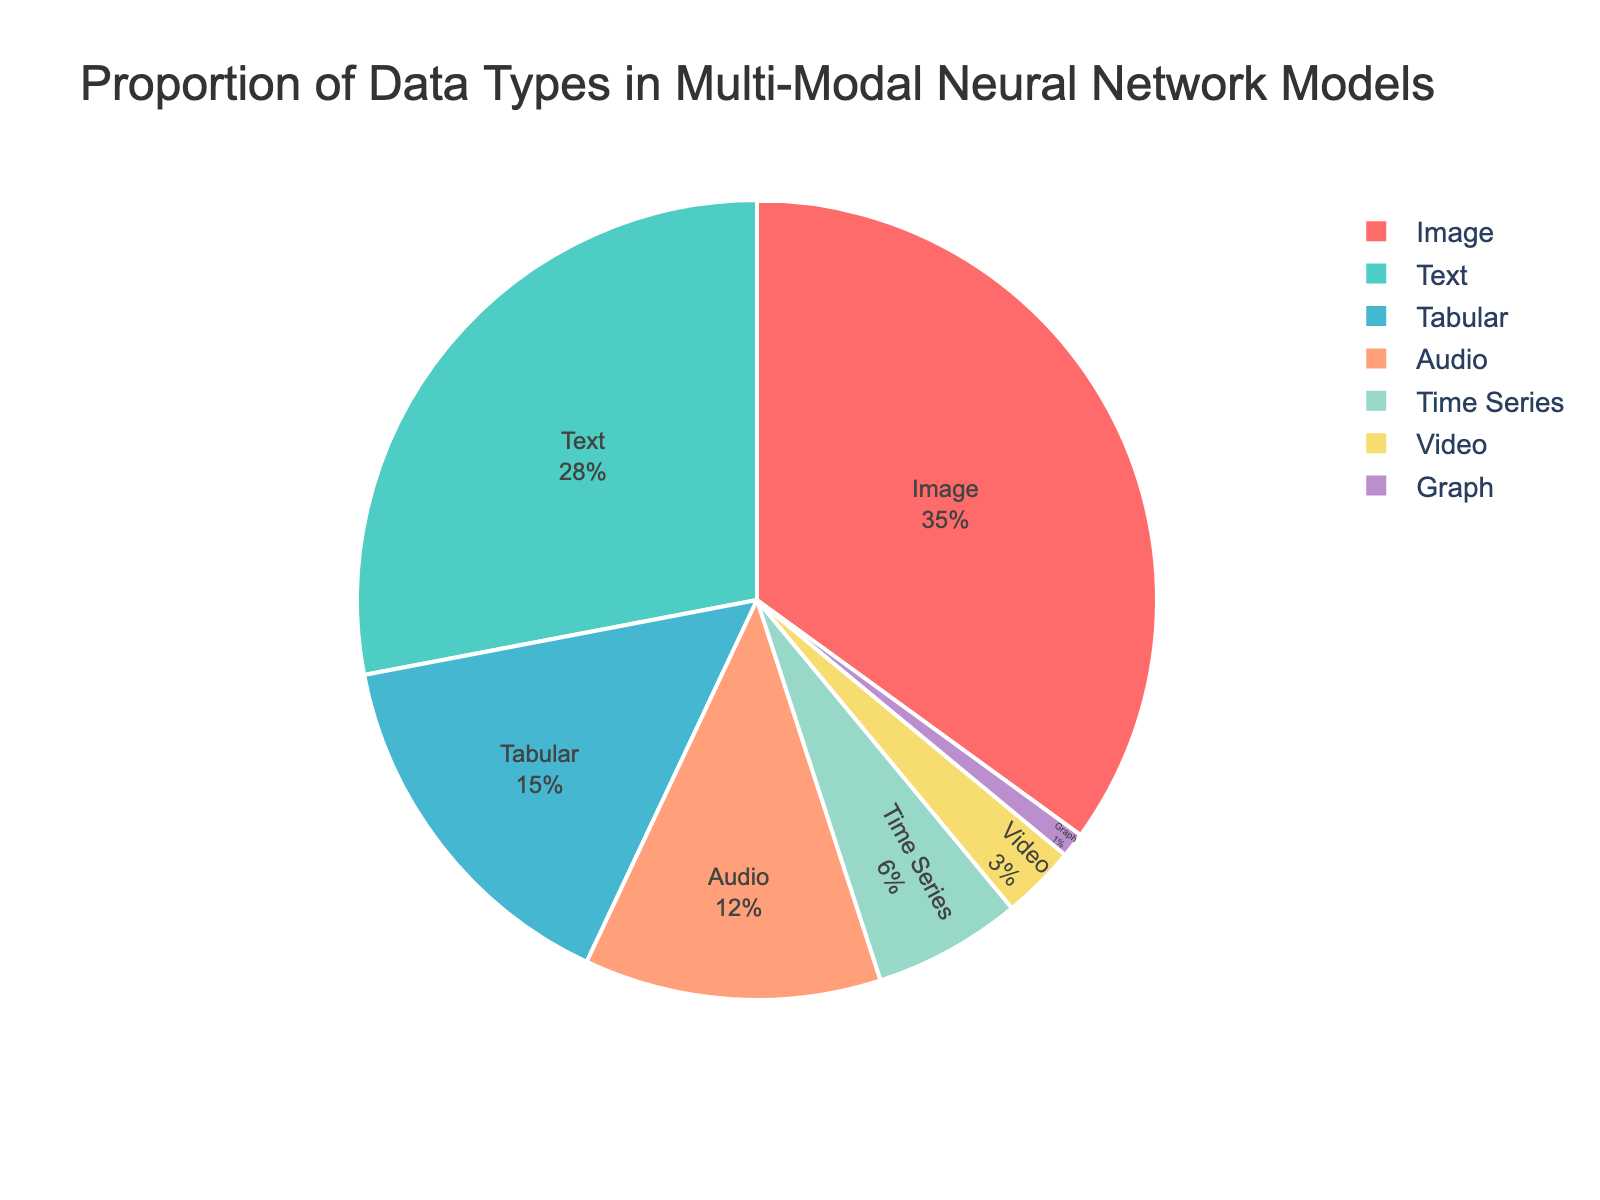What data type has the highest proportion in multi-modal neural network models? The pie chart shows various data types and their respective percentages. The largest segment represents the data type with the highest proportion, which is "Image" at 35%.
Answer: Image Which data type has the second highest proportion? By looking at the next largest segment in the pie chart after Image, we can see that "Text" has the second highest proportion at 28%.
Answer: Text What is the total percentage of Tabular and Audio data types combined? To find the total percentage of the Tabular and Audio data types, we add their percentages together. Tabular is 15% and Audio is 12%. So, 15% + 12% = 27%.
Answer: 27% Which data type has a greater proportion: Time Series or Video? By how much? By comparing the segments for Time Series and Video, we see that Time Series (6%) has a larger proportion than Video (3%). The difference is 6% - 3% = 3%.
Answer: Time Series by 3% What is the proportion of all data types except Image? The proportion of all data types except Image can be calculated by subtracting the percentage of Image from the total (100%). So, 100% - 35% = 65%.
Answer: 65% How does the proportion of Audio data compare to the proportion of Text data? To find the comparison, we look at the percentages of Audio (12%) and Text (28%). Text has a higher proportion than Audio.
Answer: Text Which data type has the smallest proportion, and what is that proportion? The smallest segment in the pie chart represents the data type with the smallest proportion. It is "Graph" with 1%.
Answer: Graph, 1% What is the combined proportion of data types that have less than 10% each? The data types with less than 10% are Time Series (6%), Video (3%), and Graph (1%). Their combined total is 6% + 3% + 1% = 10%.
Answer: 10% What is the average proportion of the four most common data types? The four most common data types are Image (35%), Text (28%), Tabular (15%), and Audio (12%). Their total is 35% + 28% + 15% + 12% = 90%. The average is 90% / 4 = 22.5%.
Answer: 22.5% Which portion of the pie chart is represented by a blue color, and what is its percentage? The portion represented by blue in the pie chart corresponds to "Tabular" data, which has a percentage of 15%.
Answer: Tabular, 15% 